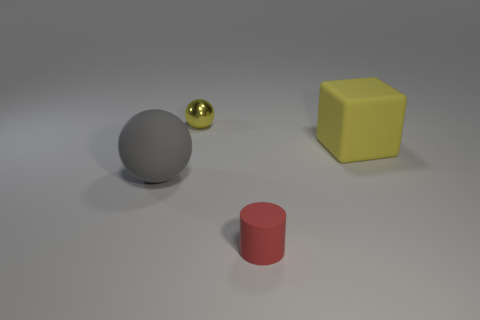Add 1 large spheres. How many objects exist? 5 Subtract all cylinders. How many objects are left? 3 Subtract all balls. Subtract all large rubber spheres. How many objects are left? 1 Add 1 large rubber objects. How many large rubber objects are left? 3 Add 1 shiny objects. How many shiny objects exist? 2 Subtract 1 gray balls. How many objects are left? 3 Subtract all blue balls. Subtract all green cylinders. How many balls are left? 2 